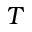Convert formula to latex. <formula><loc_0><loc_0><loc_500><loc_500>T</formula> 